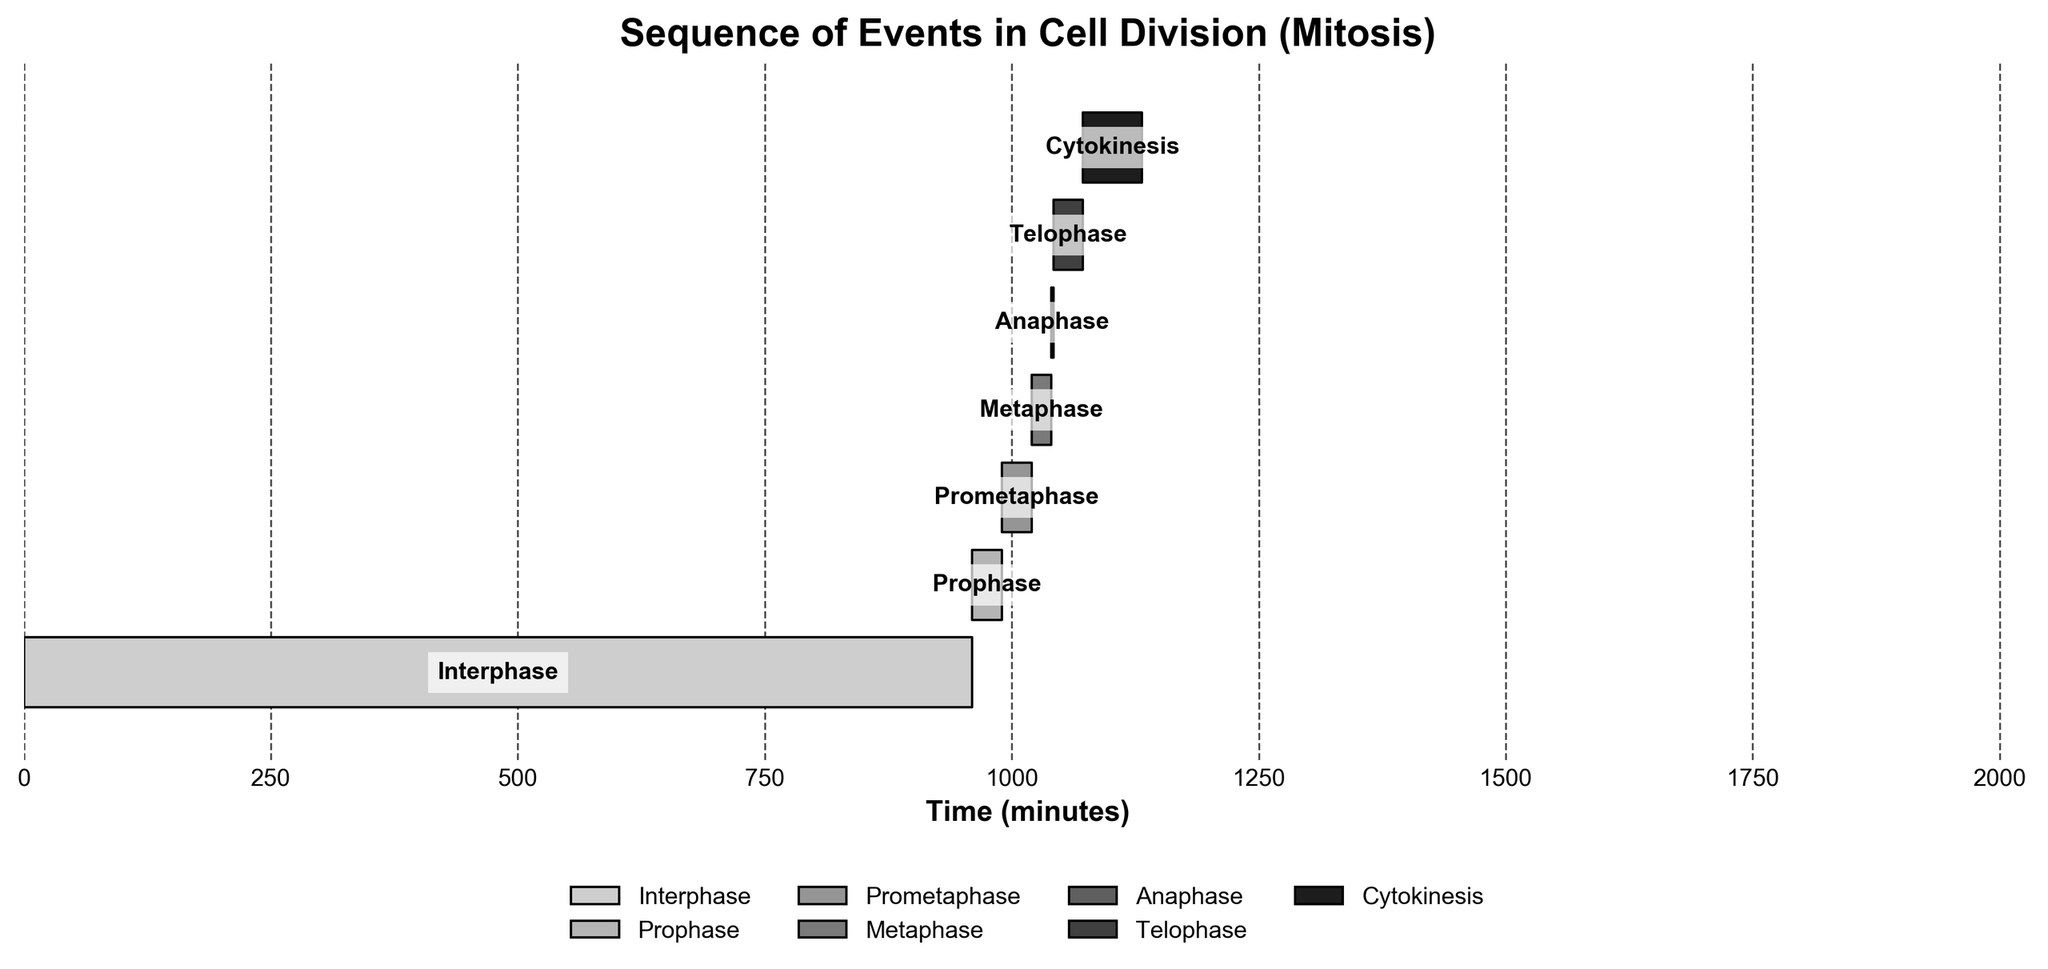What is the title of the figure? The title of the figure is typically displayed at the top of the chart. It provides an overall summary of what the chart is depicting. In this case, the title reads "Sequence of Events in Cell Division (Mitosis)."
Answer: Sequence of Events in Cell Division (Mitosis) What is the total duration of cell division (mitosis) as shown in the chart? To find the total duration, we need to look at the end time of the last event. Cytokinesis starts at 1072 minutes and lasts for 60 minutes, finishing at 1132 minutes. Therefore, the total duration of cell division is 1132 minutes.
Answer: 1132 minutes Which phase of cell division has the shortest duration? The chart displays the duration of each phase, and we can identify the shortest one by comparing these values. Anaphase lasts for only 2 minutes, making it the shortest phase.
Answer: Anaphase How long does Prometaphase last, and when does it start? To answer this, we need to refer to the chart that shows each phase’s start and duration. Prometaphase starts at 990 minutes and lasts for 30 minutes.
Answer: 30 minutes; starts at 990 minutes What is the total duration of Prophase and Metaphase combined? To find the combined duration, we need to add the durations of Prophase and Metaphase. Prophase lasts for 30 minutes and Metaphase lasts for 20 minutes. Adding these together gives 30 + 20 = 50 minutes.
Answer: 50 minutes How much longer is Cytokinesis compared to Anaphase? First, note the durations of both phases: Cytokinesis lasts for 60 minutes and Anaphase lasts for 2 minutes. Subtracting these gives 60 - 2 = 58 minutes.
Answer: 58 minutes Which phase comes immediately after Interphase? By looking at the sequence of events in the chart, Prophase is the phase that starts right after Interphase. Interphase ends at 960 minutes and Prophase starts at the same time.
Answer: Prophase How does the duration of Telophase compare to the duration of Prometaphase? Telophase has a duration of 30 minutes, and Prometaphase also has a duration of 30 minutes. Hence, both phases have equal durations.
Answer: Equal durations What is the total combined duration of all phases except Interphase? We add the durations of all phases except Interphase: Prophase (30), Prometaphase (30), Metaphase (20), Anaphase (2), Telophase (30), and Cytokinesis (60). Summing these gives 30 + 30 + 20 + 2 + 30 + 60 = 172 minutes.
Answer: 172 minutes What phase occurs at 1040 minutes? According to the chart, at 1040 minutes, Anaphase begins. The START time for Anaphase is precisely 1040 minutes, indicating its occurrence.
Answer: Anaphase 